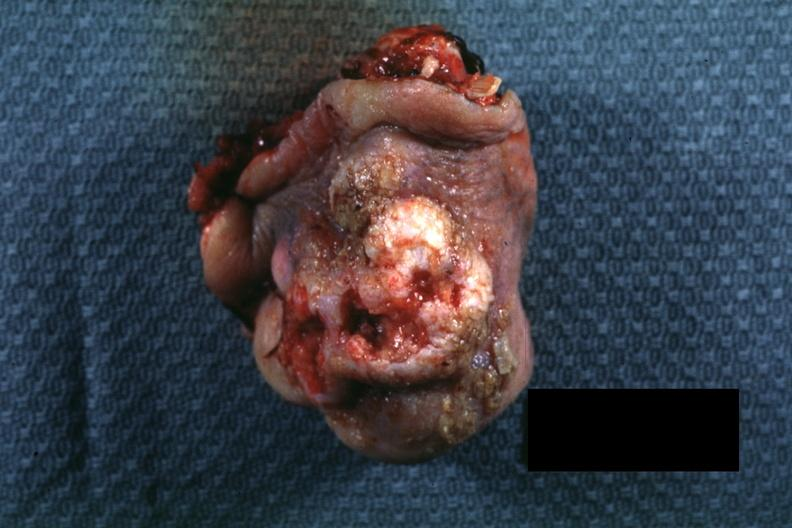s this close-up of cut surface infiltrates present?
Answer the question using a single word or phrase. No 